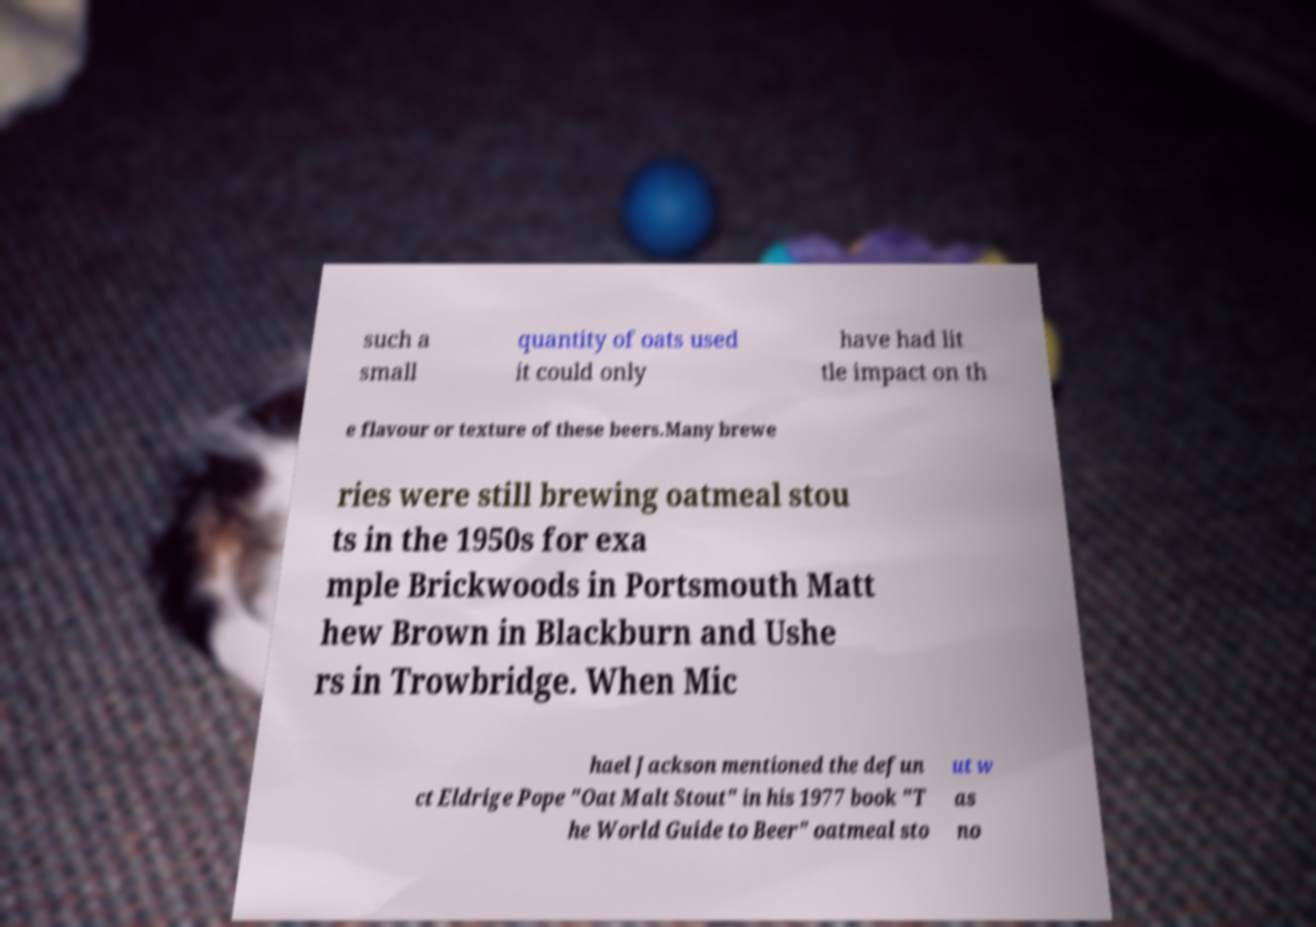Could you assist in decoding the text presented in this image and type it out clearly? such a small quantity of oats used it could only have had lit tle impact on th e flavour or texture of these beers.Many brewe ries were still brewing oatmeal stou ts in the 1950s for exa mple Brickwoods in Portsmouth Matt hew Brown in Blackburn and Ushe rs in Trowbridge. When Mic hael Jackson mentioned the defun ct Eldrige Pope "Oat Malt Stout" in his 1977 book "T he World Guide to Beer" oatmeal sto ut w as no 